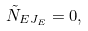<formula> <loc_0><loc_0><loc_500><loc_500>\tilde { N } _ { E J _ { E } } = 0 ,</formula> 